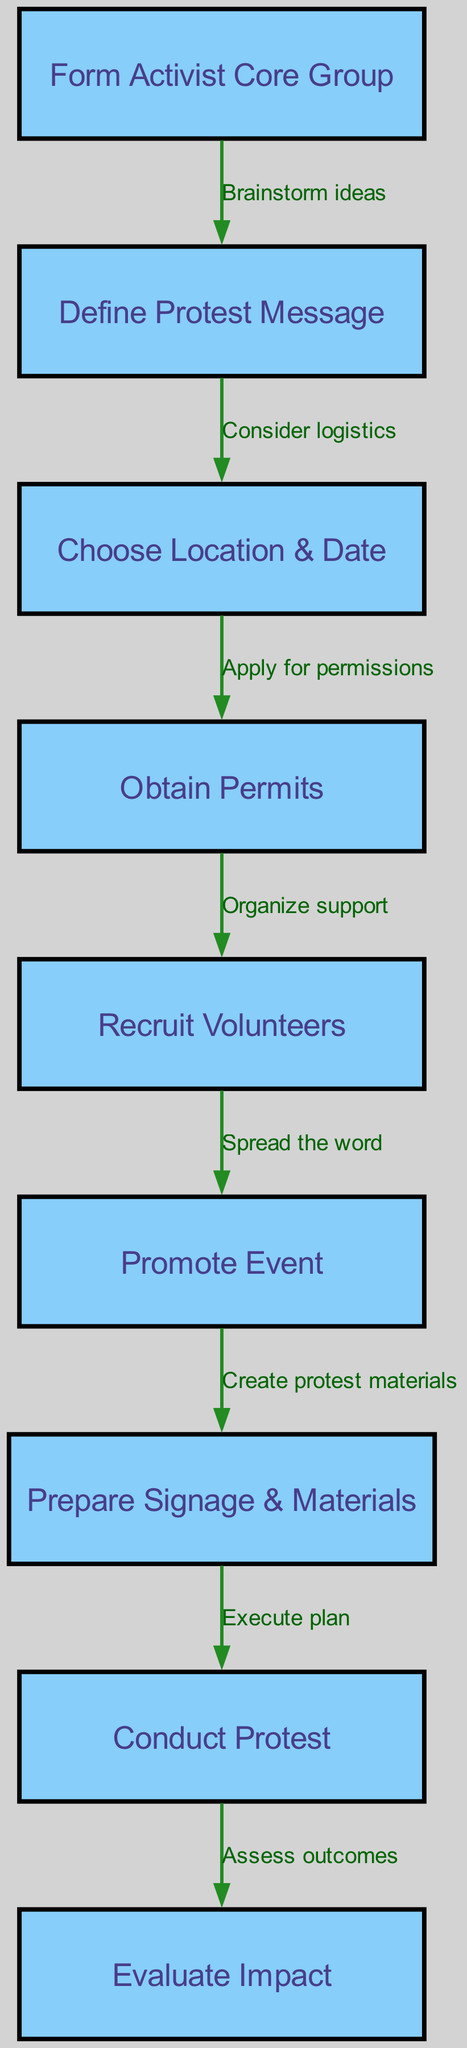What is the first step in organizing a protest? The diagram indicates that the first step is to "Form Activist Core Group," which starts the process of organizing the protest.
Answer: Form Activist Core Group How many nodes are in the diagram? Counting all the labeled elements representing the different steps, there are 9 nodes shown in the diagram.
Answer: 9 What is the last step after conducting the protest? According to the flowchart, after the protest is conducted, the next step is to "Evaluate Impact," making it the last step in the process.
Answer: Evaluate Impact What relationship exists between recruiting volunteers and promoting the event? The diagram explicitly shows that there is a directed edge from "Recruit Volunteers" to "Promote Event," indicating that once volunteers are recruited, the next task is to spread the word about the event.
Answer: Spread the word What is the relationship between defining the protest message and choosing a location? The flowchart indicates that after the "Define Protest Message" step, "Choose Location & Date" follows, meaning defining the message serves as a prerequisite for deciding where and when to hold the protest.
Answer: Consider logistics Why is obtaining permits an essential step after choosing the location and date? The diagram shows that after choosing the location and date, the process requires "Obtain Permits," which implies that securing legal permission to gather at the chosen place is critical to avoid any legal issues.
Answer: Apply for permissions What must be prepared before executing the plan? Prior to the execution of the protest as indicated by the arrow leading from "Prepare Signage & Materials" to "Conduct Protest," it's clear that all materials and signage need to be ready before the actual event.
Answer: Execute plan What step assesses the outcomes of the protest? The last node of the diagram describes the "Evaluate Impact," which is focused on understanding the results and effectiveness of the protest after it has been conducted.
Answer: Assess outcomes 